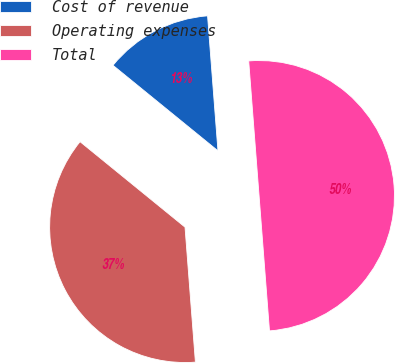Convert chart. <chart><loc_0><loc_0><loc_500><loc_500><pie_chart><fcel>Cost of revenue<fcel>Operating expenses<fcel>Total<nl><fcel>12.9%<fcel>37.1%<fcel>50.0%<nl></chart> 